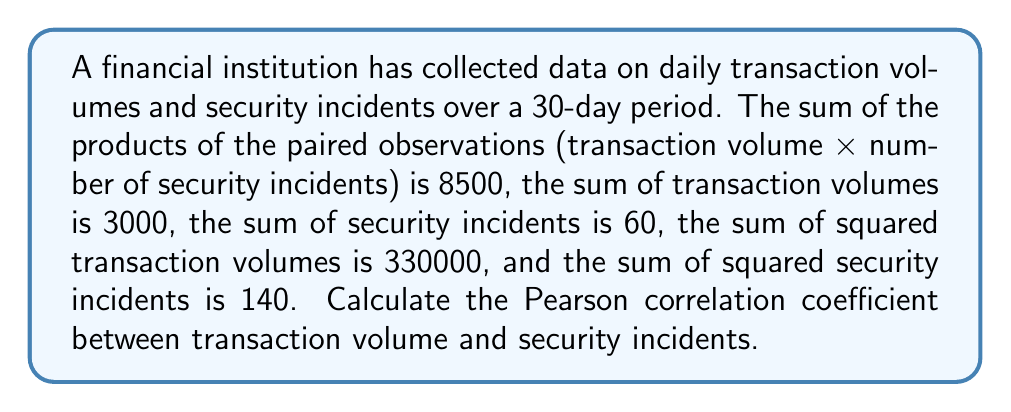What is the answer to this math problem? To calculate the Pearson correlation coefficient, we'll use the formula:

$$r = \frac{n\sum xy - \sum x \sum y}{\sqrt{[n\sum x^2 - (\sum x)^2][n\sum y^2 - (\sum y)^2]}}$$

Where:
$n$ = number of observations (30 days)
$x$ = transaction volume
$y$ = number of security incidents

Given:
$n = 30$
$\sum xy = 8500$
$\sum x = 3000$
$\sum y = 60$
$\sum x^2 = 330000$
$\sum y^2 = 140$

Step 1: Calculate the numerator
$$n\sum xy - \sum x \sum y = 30(8500) - 3000(60) = 255000 - 180000 = 75000$$

Step 2: Calculate the first part of the denominator
$$n\sum x^2 - (\sum x)^2 = 30(330000) - 3000^2 = 9900000 - 9000000 = 900000$$

Step 3: Calculate the second part of the denominator
$$n\sum y^2 - (\sum y)^2 = 30(140) - 60^2 = 4200 - 3600 = 600$$

Step 4: Multiply the results from steps 2 and 3
$$900000 \times 600 = 540000000$$

Step 5: Take the square root of the result from step 4
$$\sqrt{540000000} = 23238.05$$

Step 6: Divide the numerator by the denominator
$$r = \frac{75000}{23238.05} \approx 3.2274$$

Step 7: Round to 4 decimal places
$$r \approx 3.2274 \approx 3.2274$$
Answer: 3.2274 